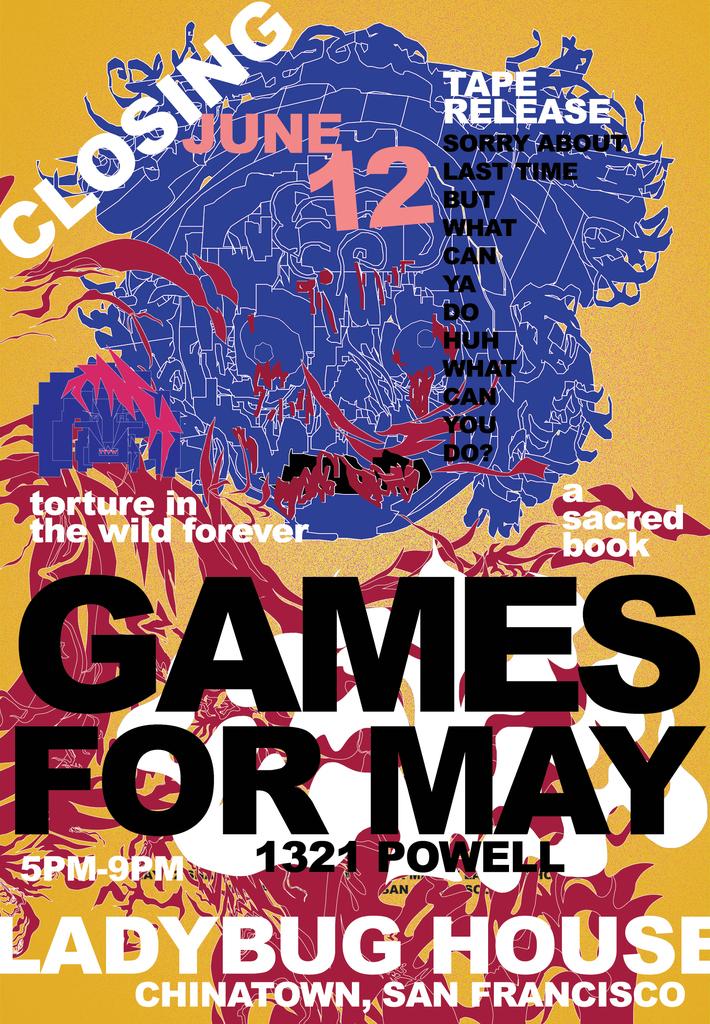Where is this event taking place?
Provide a short and direct response. Chinatown, san francisco. When is this event taking place?
Keep it short and to the point. June 12. 